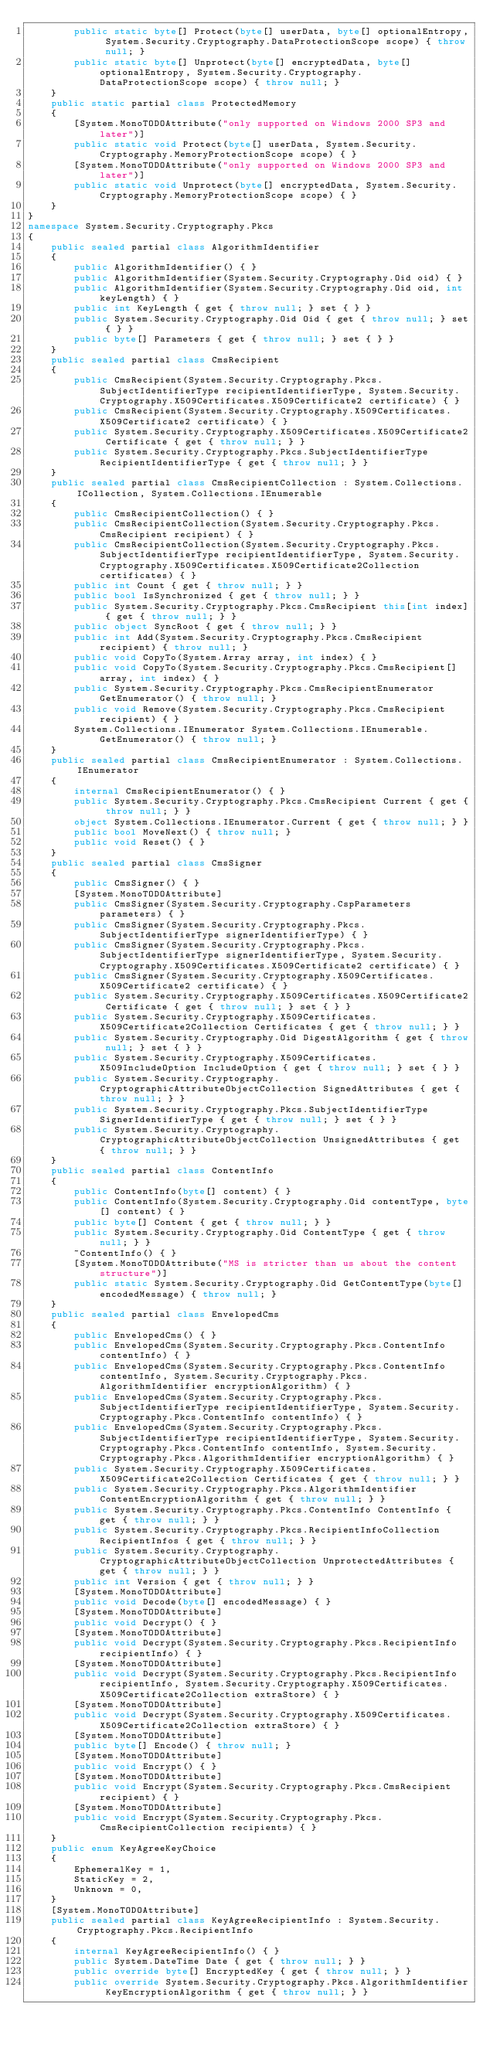<code> <loc_0><loc_0><loc_500><loc_500><_C#_>        public static byte[] Protect(byte[] userData, byte[] optionalEntropy, System.Security.Cryptography.DataProtectionScope scope) { throw null; }
        public static byte[] Unprotect(byte[] encryptedData, byte[] optionalEntropy, System.Security.Cryptography.DataProtectionScope scope) { throw null; }
    }
    public static partial class ProtectedMemory
    {
        [System.MonoTODOAttribute("only supported on Windows 2000 SP3 and later")]
        public static void Protect(byte[] userData, System.Security.Cryptography.MemoryProtectionScope scope) { }
        [System.MonoTODOAttribute("only supported on Windows 2000 SP3 and later")]
        public static void Unprotect(byte[] encryptedData, System.Security.Cryptography.MemoryProtectionScope scope) { }
    }
}
namespace System.Security.Cryptography.Pkcs
{
    public sealed partial class AlgorithmIdentifier
    {
        public AlgorithmIdentifier() { }
        public AlgorithmIdentifier(System.Security.Cryptography.Oid oid) { }
        public AlgorithmIdentifier(System.Security.Cryptography.Oid oid, int keyLength) { }
        public int KeyLength { get { throw null; } set { } }
        public System.Security.Cryptography.Oid Oid { get { throw null; } set { } }
        public byte[] Parameters { get { throw null; } set { } }
    }
    public sealed partial class CmsRecipient
    {
        public CmsRecipient(System.Security.Cryptography.Pkcs.SubjectIdentifierType recipientIdentifierType, System.Security.Cryptography.X509Certificates.X509Certificate2 certificate) { }
        public CmsRecipient(System.Security.Cryptography.X509Certificates.X509Certificate2 certificate) { }
        public System.Security.Cryptography.X509Certificates.X509Certificate2 Certificate { get { throw null; } }
        public System.Security.Cryptography.Pkcs.SubjectIdentifierType RecipientIdentifierType { get { throw null; } }
    }
    public sealed partial class CmsRecipientCollection : System.Collections.ICollection, System.Collections.IEnumerable
    {
        public CmsRecipientCollection() { }
        public CmsRecipientCollection(System.Security.Cryptography.Pkcs.CmsRecipient recipient) { }
        public CmsRecipientCollection(System.Security.Cryptography.Pkcs.SubjectIdentifierType recipientIdentifierType, System.Security.Cryptography.X509Certificates.X509Certificate2Collection certificates) { }
        public int Count { get { throw null; } }
        public bool IsSynchronized { get { throw null; } }
        public System.Security.Cryptography.Pkcs.CmsRecipient this[int index] { get { throw null; } }
        public object SyncRoot { get { throw null; } }
        public int Add(System.Security.Cryptography.Pkcs.CmsRecipient recipient) { throw null; }
        public void CopyTo(System.Array array, int index) { }
        public void CopyTo(System.Security.Cryptography.Pkcs.CmsRecipient[] array, int index) { }
        public System.Security.Cryptography.Pkcs.CmsRecipientEnumerator GetEnumerator() { throw null; }
        public void Remove(System.Security.Cryptography.Pkcs.CmsRecipient recipient) { }
        System.Collections.IEnumerator System.Collections.IEnumerable.GetEnumerator() { throw null; }
    }
    public sealed partial class CmsRecipientEnumerator : System.Collections.IEnumerator
    {
        internal CmsRecipientEnumerator() { }
        public System.Security.Cryptography.Pkcs.CmsRecipient Current { get { throw null; } }
        object System.Collections.IEnumerator.Current { get { throw null; } }
        public bool MoveNext() { throw null; }
        public void Reset() { }
    }
    public sealed partial class CmsSigner
    {
        public CmsSigner() { }
        [System.MonoTODOAttribute]
        public CmsSigner(System.Security.Cryptography.CspParameters parameters) { }
        public CmsSigner(System.Security.Cryptography.Pkcs.SubjectIdentifierType signerIdentifierType) { }
        public CmsSigner(System.Security.Cryptography.Pkcs.SubjectIdentifierType signerIdentifierType, System.Security.Cryptography.X509Certificates.X509Certificate2 certificate) { }
        public CmsSigner(System.Security.Cryptography.X509Certificates.X509Certificate2 certificate) { }
        public System.Security.Cryptography.X509Certificates.X509Certificate2 Certificate { get { throw null; } set { } }
        public System.Security.Cryptography.X509Certificates.X509Certificate2Collection Certificates { get { throw null; } }
        public System.Security.Cryptography.Oid DigestAlgorithm { get { throw null; } set { } }
        public System.Security.Cryptography.X509Certificates.X509IncludeOption IncludeOption { get { throw null; } set { } }
        public System.Security.Cryptography.CryptographicAttributeObjectCollection SignedAttributes { get { throw null; } }
        public System.Security.Cryptography.Pkcs.SubjectIdentifierType SignerIdentifierType { get { throw null; } set { } }
        public System.Security.Cryptography.CryptographicAttributeObjectCollection UnsignedAttributes { get { throw null; } }
    }
    public sealed partial class ContentInfo
    {
        public ContentInfo(byte[] content) { }
        public ContentInfo(System.Security.Cryptography.Oid contentType, byte[] content) { }
        public byte[] Content { get { throw null; } }
        public System.Security.Cryptography.Oid ContentType { get { throw null; } }
        ~ContentInfo() { }
        [System.MonoTODOAttribute("MS is stricter than us about the content structure")]
        public static System.Security.Cryptography.Oid GetContentType(byte[] encodedMessage) { throw null; }
    }
    public sealed partial class EnvelopedCms
    {
        public EnvelopedCms() { }
        public EnvelopedCms(System.Security.Cryptography.Pkcs.ContentInfo contentInfo) { }
        public EnvelopedCms(System.Security.Cryptography.Pkcs.ContentInfo contentInfo, System.Security.Cryptography.Pkcs.AlgorithmIdentifier encryptionAlgorithm) { }
        public EnvelopedCms(System.Security.Cryptography.Pkcs.SubjectIdentifierType recipientIdentifierType, System.Security.Cryptography.Pkcs.ContentInfo contentInfo) { }
        public EnvelopedCms(System.Security.Cryptography.Pkcs.SubjectIdentifierType recipientIdentifierType, System.Security.Cryptography.Pkcs.ContentInfo contentInfo, System.Security.Cryptography.Pkcs.AlgorithmIdentifier encryptionAlgorithm) { }
        public System.Security.Cryptography.X509Certificates.X509Certificate2Collection Certificates { get { throw null; } }
        public System.Security.Cryptography.Pkcs.AlgorithmIdentifier ContentEncryptionAlgorithm { get { throw null; } }
        public System.Security.Cryptography.Pkcs.ContentInfo ContentInfo { get { throw null; } }
        public System.Security.Cryptography.Pkcs.RecipientInfoCollection RecipientInfos { get { throw null; } }
        public System.Security.Cryptography.CryptographicAttributeObjectCollection UnprotectedAttributes { get { throw null; } }
        public int Version { get { throw null; } }
        [System.MonoTODOAttribute]
        public void Decode(byte[] encodedMessage) { }
        [System.MonoTODOAttribute]
        public void Decrypt() { }
        [System.MonoTODOAttribute]
        public void Decrypt(System.Security.Cryptography.Pkcs.RecipientInfo recipientInfo) { }
        [System.MonoTODOAttribute]
        public void Decrypt(System.Security.Cryptography.Pkcs.RecipientInfo recipientInfo, System.Security.Cryptography.X509Certificates.X509Certificate2Collection extraStore) { }
        [System.MonoTODOAttribute]
        public void Decrypt(System.Security.Cryptography.X509Certificates.X509Certificate2Collection extraStore) { }
        [System.MonoTODOAttribute]
        public byte[] Encode() { throw null; }
        [System.MonoTODOAttribute]
        public void Encrypt() { }
        [System.MonoTODOAttribute]
        public void Encrypt(System.Security.Cryptography.Pkcs.CmsRecipient recipient) { }
        [System.MonoTODOAttribute]
        public void Encrypt(System.Security.Cryptography.Pkcs.CmsRecipientCollection recipients) { }
    }
    public enum KeyAgreeKeyChoice
    {
        EphemeralKey = 1,
        StaticKey = 2,
        Unknown = 0,
    }
    [System.MonoTODOAttribute]
    public sealed partial class KeyAgreeRecipientInfo : System.Security.Cryptography.Pkcs.RecipientInfo
    {
        internal KeyAgreeRecipientInfo() { }
        public System.DateTime Date { get { throw null; } }
        public override byte[] EncryptedKey { get { throw null; } }
        public override System.Security.Cryptography.Pkcs.AlgorithmIdentifier KeyEncryptionAlgorithm { get { throw null; } }</code> 